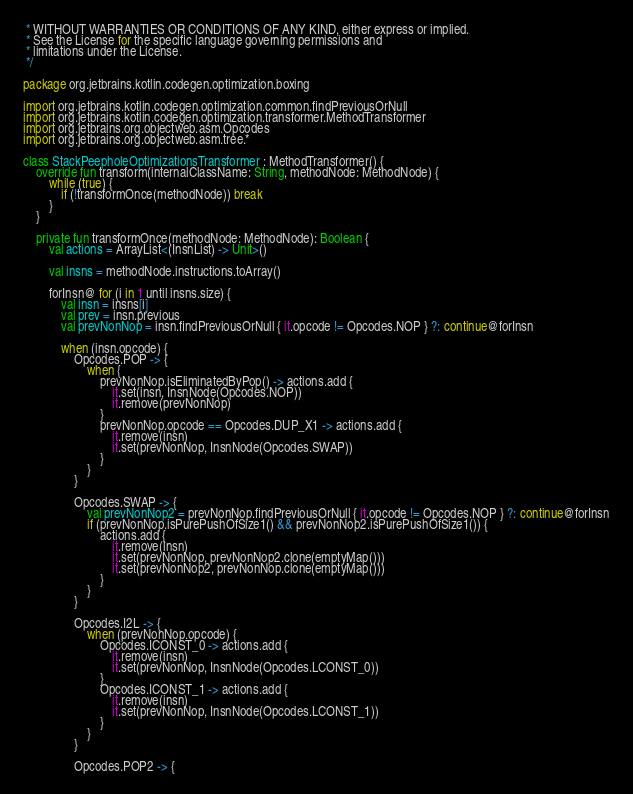<code> <loc_0><loc_0><loc_500><loc_500><_Kotlin_> * WITHOUT WARRANTIES OR CONDITIONS OF ANY KIND, either express or implied.
 * See the License for the specific language governing permissions and
 * limitations under the License.
 */

package org.jetbrains.kotlin.codegen.optimization.boxing

import org.jetbrains.kotlin.codegen.optimization.common.findPreviousOrNull
import org.jetbrains.kotlin.codegen.optimization.transformer.MethodTransformer
import org.jetbrains.org.objectweb.asm.Opcodes
import org.jetbrains.org.objectweb.asm.tree.*

class StackPeepholeOptimizationsTransformer : MethodTransformer() {
    override fun transform(internalClassName: String, methodNode: MethodNode) {
        while (true) {
            if (!transformOnce(methodNode)) break
        }
    }

    private fun transformOnce(methodNode: MethodNode): Boolean {
        val actions = ArrayList<(InsnList) -> Unit>()

        val insns = methodNode.instructions.toArray()

        forInsn@ for (i in 1 until insns.size) {
            val insn = insns[i]
            val prev = insn.previous
            val prevNonNop = insn.findPreviousOrNull { it.opcode != Opcodes.NOP } ?: continue@forInsn

            when (insn.opcode) {
                Opcodes.POP -> {
                    when {
                        prevNonNop.isEliminatedByPop() -> actions.add {
                            it.set(insn, InsnNode(Opcodes.NOP))
                            it.remove(prevNonNop)
                        }
                        prevNonNop.opcode == Opcodes.DUP_X1 -> actions.add {
                            it.remove(insn)
                            it.set(prevNonNop, InsnNode(Opcodes.SWAP))
                        }
                    }
                }

                Opcodes.SWAP -> {
                    val prevNonNop2 = prevNonNop.findPreviousOrNull { it.opcode != Opcodes.NOP } ?: continue@forInsn
                    if (prevNonNop.isPurePushOfSize1() && prevNonNop2.isPurePushOfSize1()) {
                        actions.add {
                            it.remove(insn)
                            it.set(prevNonNop, prevNonNop2.clone(emptyMap()))
                            it.set(prevNonNop2, prevNonNop.clone(emptyMap()))
                        }
                    }
                }

                Opcodes.I2L -> {
                    when (prevNonNop.opcode) {
                        Opcodes.ICONST_0 -> actions.add {
                            it.remove(insn)
                            it.set(prevNonNop, InsnNode(Opcodes.LCONST_0))
                        }
                        Opcodes.ICONST_1 -> actions.add {
                            it.remove(insn)
                            it.set(prevNonNop, InsnNode(Opcodes.LCONST_1))
                        }
                    }
                }

                Opcodes.POP2 -> {</code> 